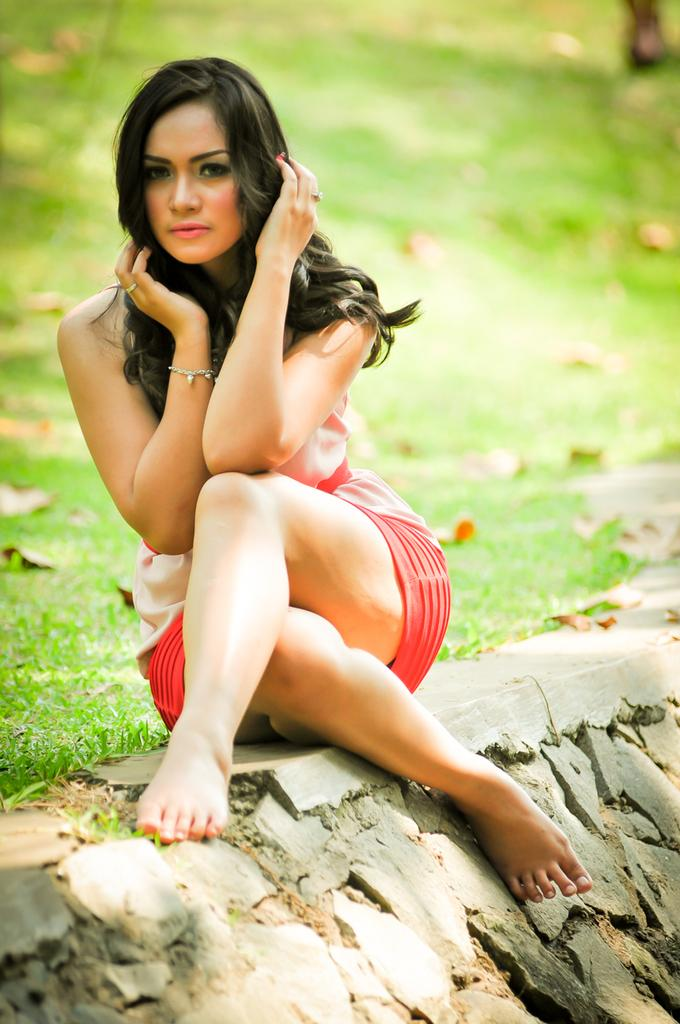What is the person in the image doing? The person is sitting on a wall in the image. What can be seen in the background of the image? There is grass visible in the background of the image. What direction does the person start walking in the image? There is no indication in the image that the person is walking or has started walking in any direction. 